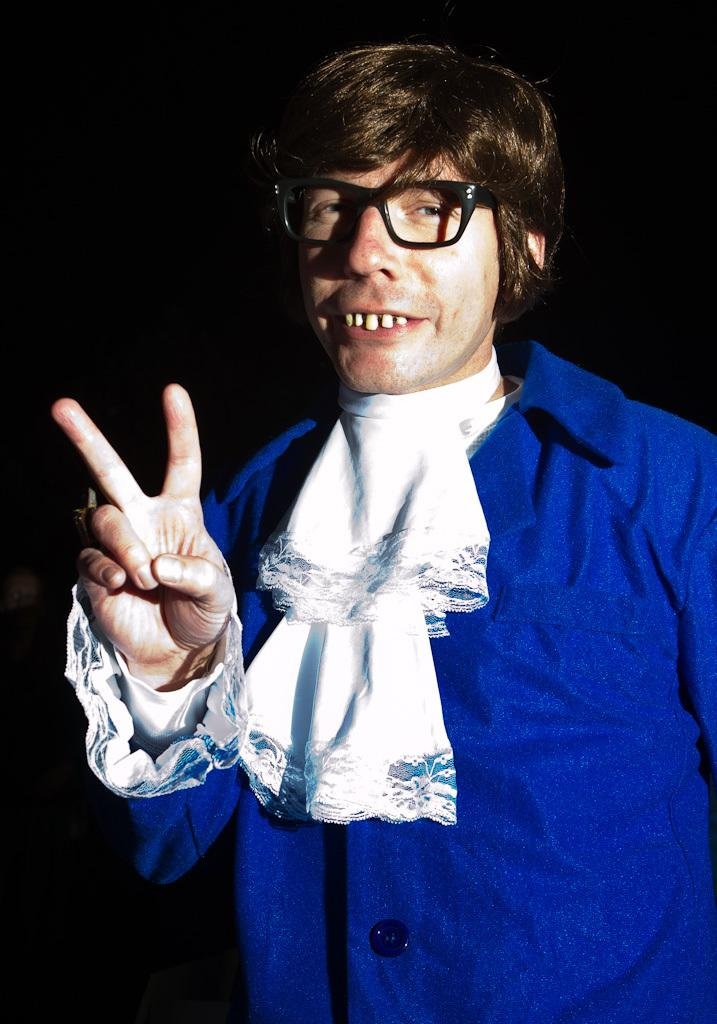Who is present in the image? There is a man in the image. What can be observed about the background of the image? The background of the image is dark. What type of dress is the man wearing in the image? The man is not wearing a dress in the image, as the facts provided do not mention any clothing details. 